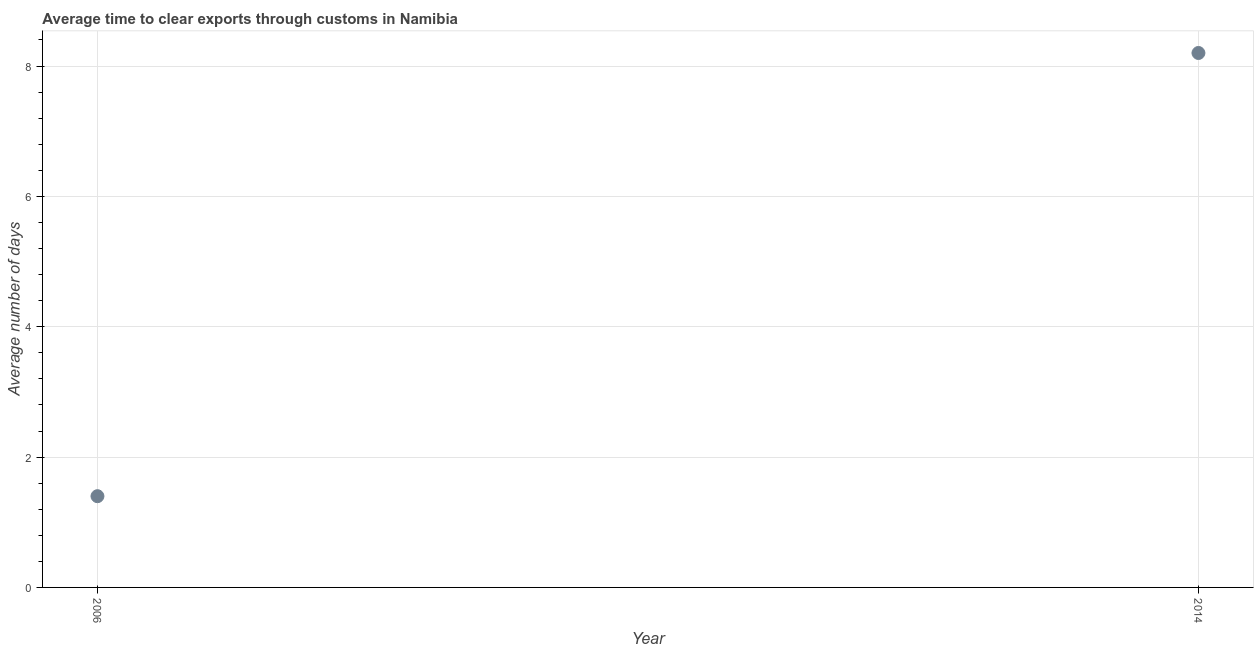What is the time to clear exports through customs in 2014?
Provide a succinct answer. 8.2. Across all years, what is the maximum time to clear exports through customs?
Give a very brief answer. 8.2. In which year was the time to clear exports through customs minimum?
Offer a very short reply. 2006. What is the sum of the time to clear exports through customs?
Provide a short and direct response. 9.6. What is the difference between the time to clear exports through customs in 2006 and 2014?
Provide a succinct answer. -6.8. What is the average time to clear exports through customs per year?
Your response must be concise. 4.8. What is the median time to clear exports through customs?
Offer a very short reply. 4.8. In how many years, is the time to clear exports through customs greater than 3.2 days?
Ensure brevity in your answer.  1. Do a majority of the years between 2006 and 2014 (inclusive) have time to clear exports through customs greater than 7.6 days?
Offer a very short reply. No. What is the ratio of the time to clear exports through customs in 2006 to that in 2014?
Offer a very short reply. 0.17. Is the time to clear exports through customs in 2006 less than that in 2014?
Make the answer very short. Yes. In how many years, is the time to clear exports through customs greater than the average time to clear exports through customs taken over all years?
Offer a very short reply. 1. What is the difference between two consecutive major ticks on the Y-axis?
Ensure brevity in your answer.  2. What is the title of the graph?
Your answer should be very brief. Average time to clear exports through customs in Namibia. What is the label or title of the X-axis?
Offer a terse response. Year. What is the label or title of the Y-axis?
Give a very brief answer. Average number of days. What is the Average number of days in 2014?
Offer a very short reply. 8.2. What is the difference between the Average number of days in 2006 and 2014?
Provide a short and direct response. -6.8. What is the ratio of the Average number of days in 2006 to that in 2014?
Ensure brevity in your answer.  0.17. 